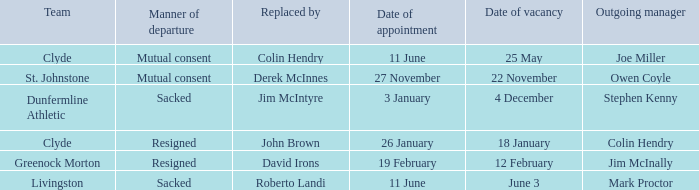Tell me the manner of departure for 3 january date of appointment Sacked. 